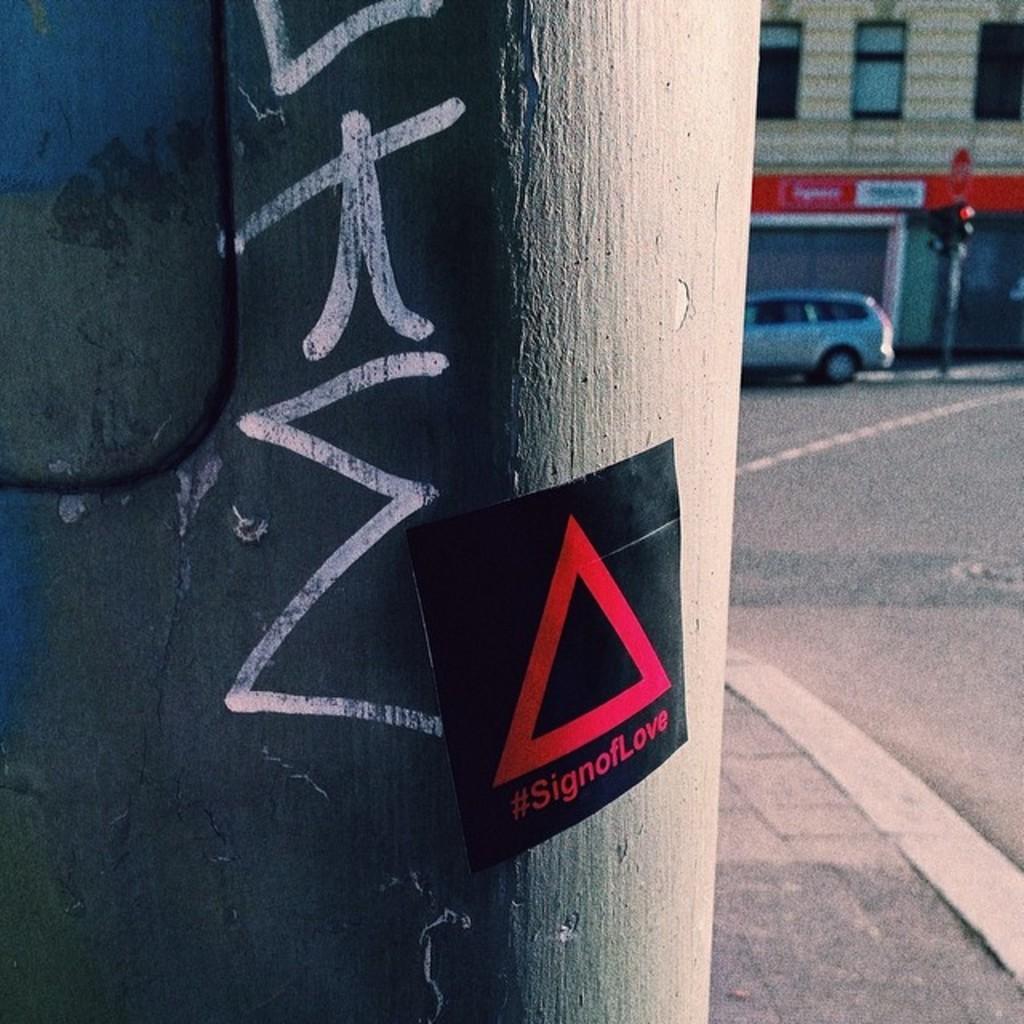In one or two sentences, can you explain what this image depicts? In this image on the left side there is a wall, on the wall there is one poster and wire. In the background there is a building, pole, traffic signals and car. At the bottom there is walkway. 